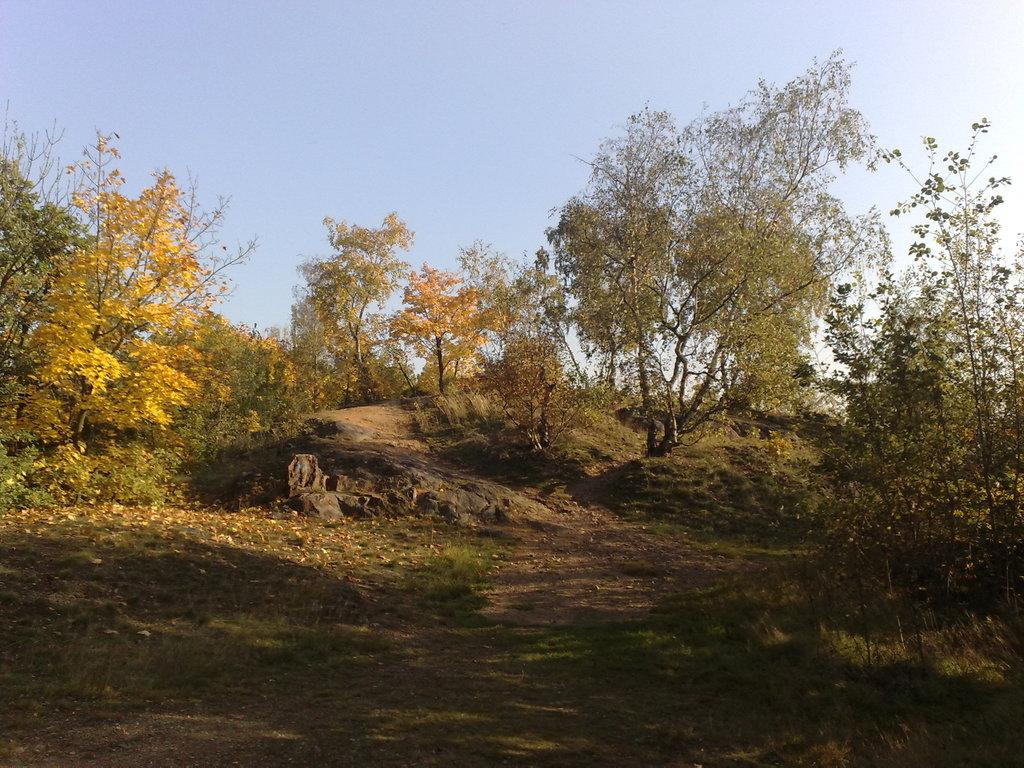What type of natural elements can be seen in the image? There are rocks and trees in the image. What can be seen in the background of the image? The sky is visible in the background of the image. What type of vegetation is present in the image? There is grass on the surface at the bottom of the image. What type of lock can be seen securing the pear in the image? There is no lock or pear present in the image; it features rocks, trees, and grass. 